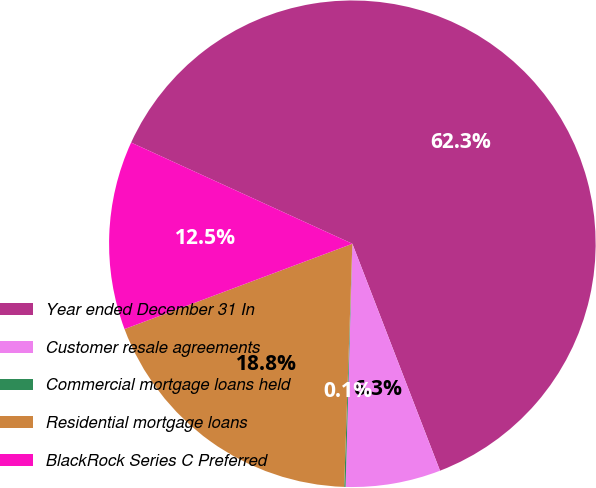<chart> <loc_0><loc_0><loc_500><loc_500><pie_chart><fcel>Year ended December 31 In<fcel>Customer resale agreements<fcel>Commercial mortgage loans held<fcel>Residential mortgage loans<fcel>BlackRock Series C Preferred<nl><fcel>62.3%<fcel>6.31%<fcel>0.09%<fcel>18.76%<fcel>12.53%<nl></chart> 